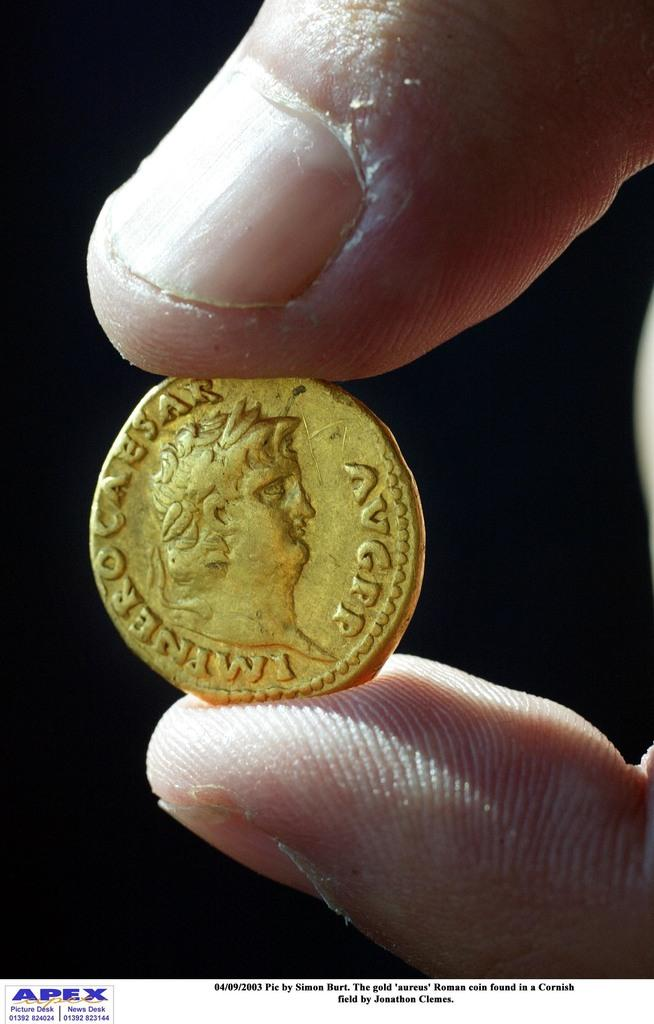What is present in the image? There is a person in the image. What is the person holding? The person is holding a coin. What type of poison is the person using to plough the field in the image? There is no plough or poison present in the image; it only features a person holding a coin. 